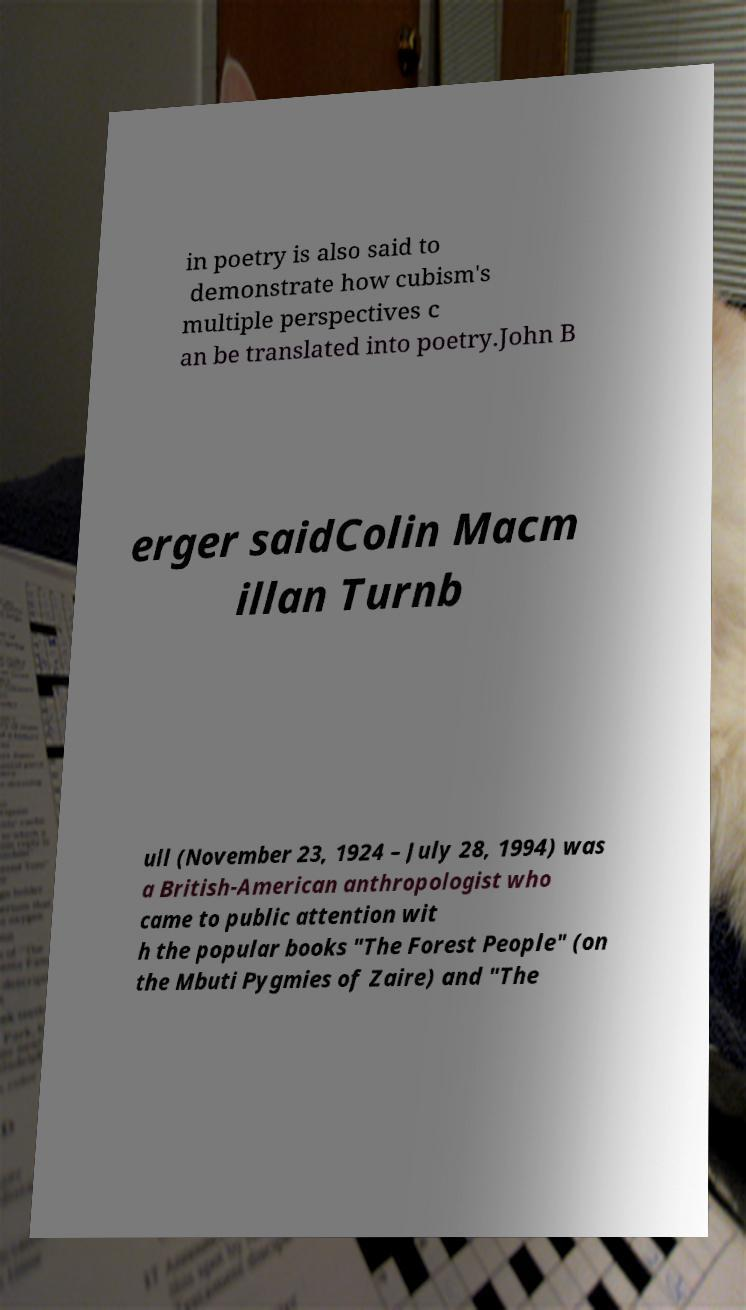Can you accurately transcribe the text from the provided image for me? in poetry is also said to demonstrate how cubism's multiple perspectives c an be translated into poetry.John B erger saidColin Macm illan Turnb ull (November 23, 1924 – July 28, 1994) was a British-American anthropologist who came to public attention wit h the popular books "The Forest People" (on the Mbuti Pygmies of Zaire) and "The 